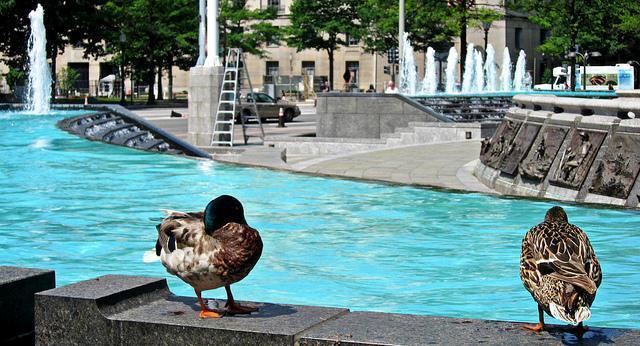How many ducks are here?
Give a very brief answer. 2. How many birds are visible?
Give a very brief answer. 2. 